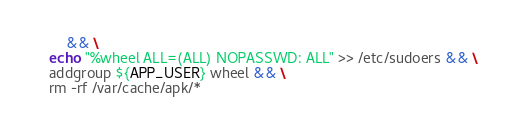<code> <loc_0><loc_0><loc_500><loc_500><_Dockerfile_>        && \
    echo "%wheel ALL=(ALL) NOPASSWD: ALL" >> /etc/sudoers && \
    addgroup ${APP_USER} wheel && \
    rm -rf /var/cache/apk/*
</code> 